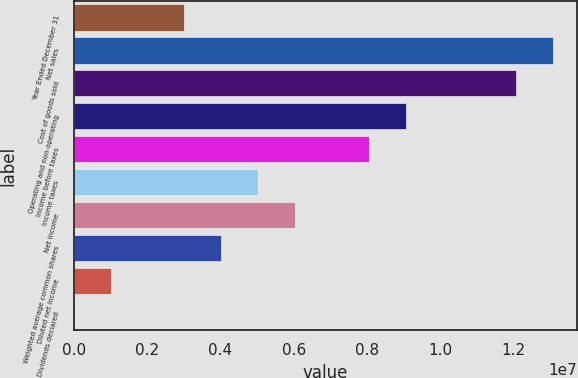<chart> <loc_0><loc_0><loc_500><loc_500><bar_chart><fcel>Year Ended December 31<fcel>Net sales<fcel>Cost of goods sold<fcel>Operating and non-operating<fcel>Income before taxes<fcel>Income taxes<fcel>Net income<fcel>Weighted average common shares<fcel>Diluted net income<fcel>Dividends declared<nl><fcel>3.01725e+06<fcel>1.30748e+07<fcel>1.2069e+07<fcel>9.05176e+06<fcel>8.04601e+06<fcel>5.02876e+06<fcel>6.03451e+06<fcel>4.02301e+06<fcel>1.00575e+06<fcel>1.6<nl></chart> 